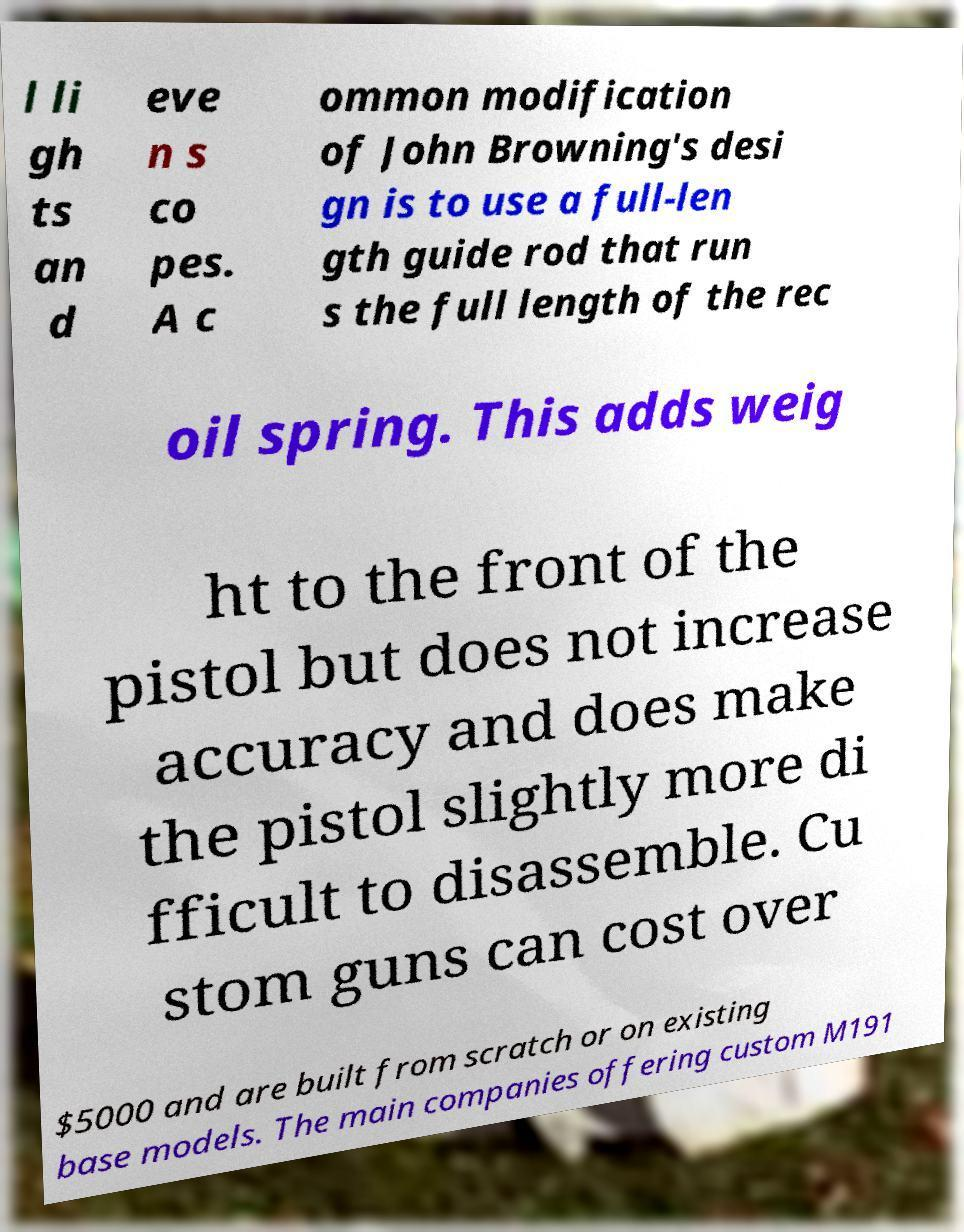Could you extract and type out the text from this image? l li gh ts an d eve n s co pes. A c ommon modification of John Browning's desi gn is to use a full-len gth guide rod that run s the full length of the rec oil spring. This adds weig ht to the front of the pistol but does not increase accuracy and does make the pistol slightly more di fficult to disassemble. Cu stom guns can cost over $5000 and are built from scratch or on existing base models. The main companies offering custom M191 